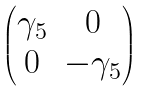Convert formula to latex. <formula><loc_0><loc_0><loc_500><loc_500>\begin{pmatrix} \gamma _ { 5 } & 0 \\ 0 & - \gamma _ { 5 } \end{pmatrix}</formula> 